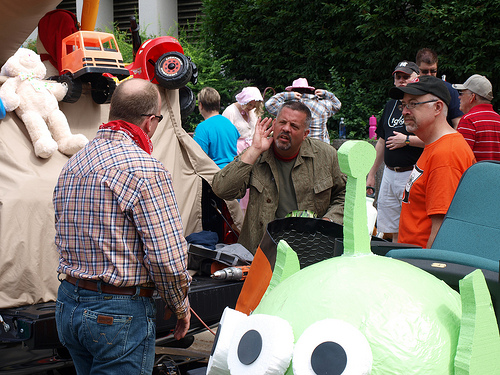<image>
Is the man on the chair? No. The man is not positioned on the chair. They may be near each other, but the man is not supported by or resting on top of the chair. 